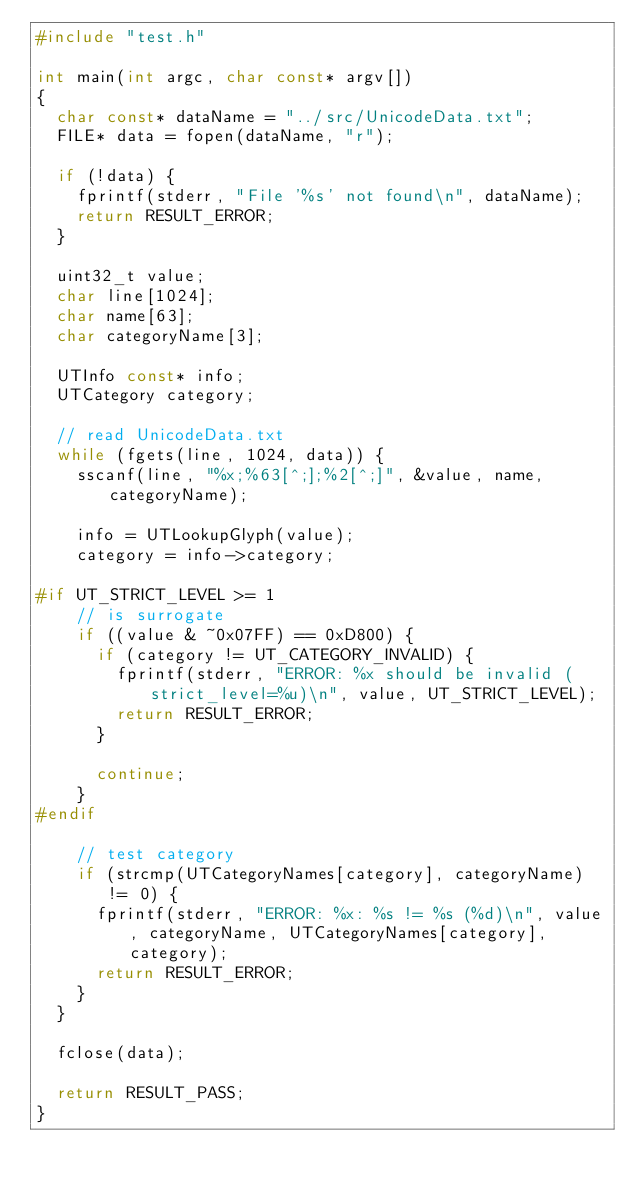<code> <loc_0><loc_0><loc_500><loc_500><_C_>#include "test.h"

int main(int argc, char const* argv[])
{
	char const* dataName = "../src/UnicodeData.txt";
	FILE* data = fopen(dataName, "r");

	if (!data) {
		fprintf(stderr, "File '%s' not found\n", dataName);
		return RESULT_ERROR;
	}

	uint32_t value;
	char line[1024];
	char name[63];
	char categoryName[3];

	UTInfo const* info;
	UTCategory category;

	// read UnicodeData.txt
	while (fgets(line, 1024, data)) {
		sscanf(line, "%x;%63[^;];%2[^;]", &value, name, categoryName);

		info = UTLookupGlyph(value);
		category = info->category;

#if UT_STRICT_LEVEL >= 1
		// is surrogate
		if ((value & ~0x07FF) == 0xD800) {
			if (category != UT_CATEGORY_INVALID) {
				fprintf(stderr, "ERROR: %x should be invalid (strict_level=%u)\n", value, UT_STRICT_LEVEL);
				return RESULT_ERROR;
			}

			continue;
		}
#endif

		// test category
		if (strcmp(UTCategoryNames[category], categoryName) != 0) {
			fprintf(stderr, "ERROR: %x: %s != %s (%d)\n", value, categoryName, UTCategoryNames[category], category);
			return RESULT_ERROR;
		}
	}

	fclose(data);

	return RESULT_PASS;
}
</code> 